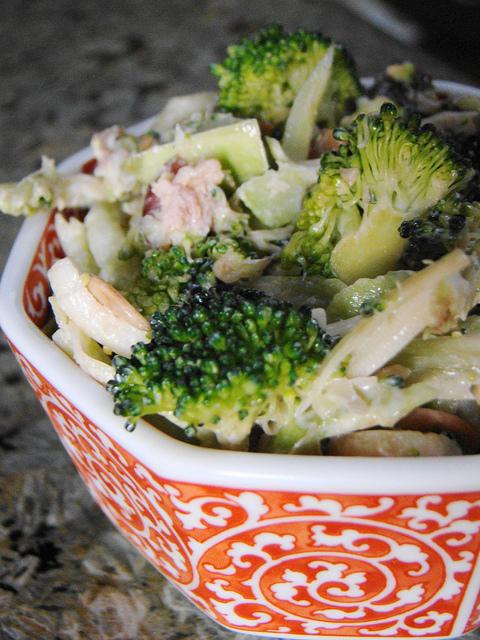What green vegetable is in this bowl?
Write a very short answer. Broccoli. What kind of pattern is on the bowl?
Answer briefly. Oriental. Is this a healthy food?
Quick response, please. Yes. What color is the bowl?
Quick response, please. Orange and white. Do you see more than one kind of green vegetable?
Write a very short answer. No. 